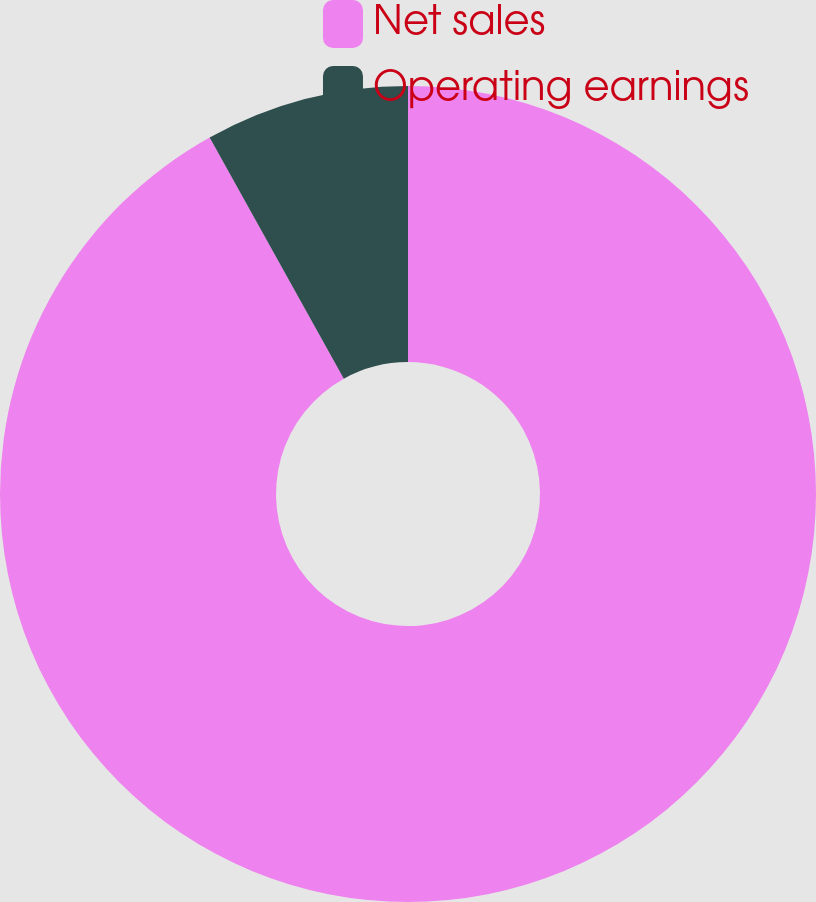Convert chart to OTSL. <chart><loc_0><loc_0><loc_500><loc_500><pie_chart><fcel>Net sales<fcel>Operating earnings<nl><fcel>91.92%<fcel>8.08%<nl></chart> 